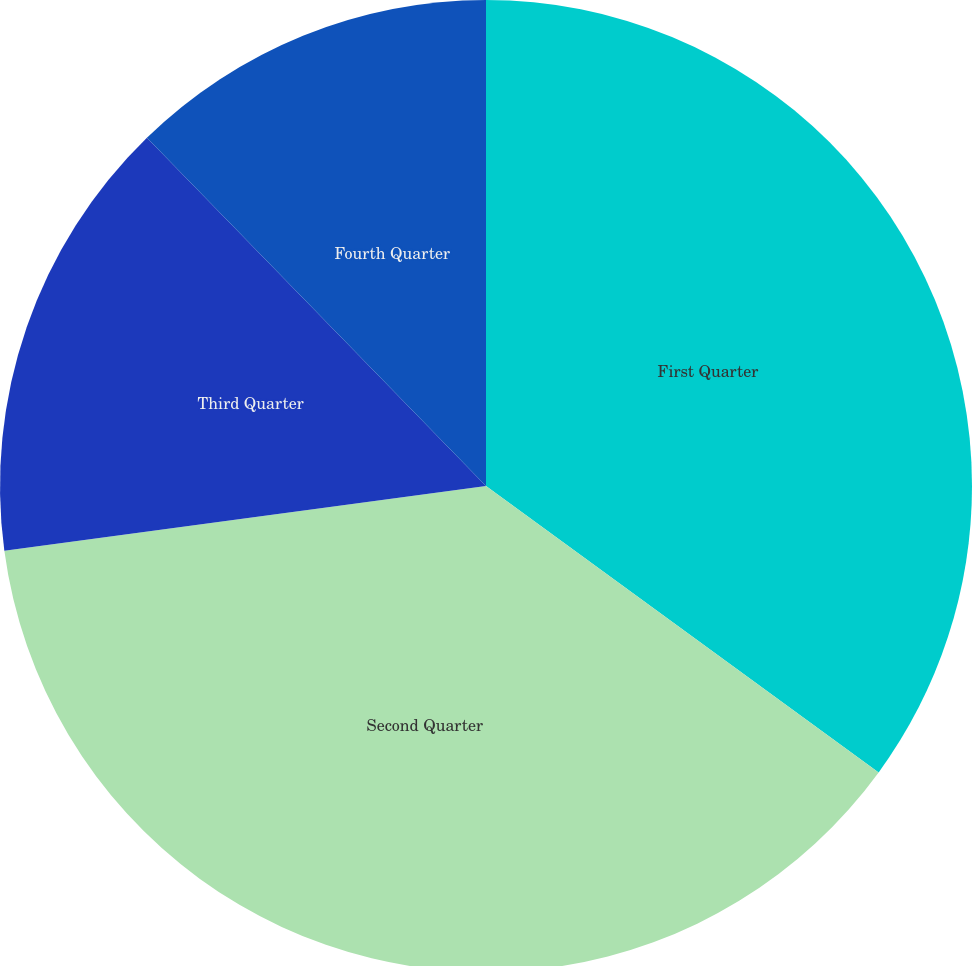<chart> <loc_0><loc_0><loc_500><loc_500><pie_chart><fcel>First Quarter<fcel>Second Quarter<fcel>Third Quarter<fcel>Fourth Quarter<nl><fcel>35.03%<fcel>37.84%<fcel>14.84%<fcel>12.29%<nl></chart> 